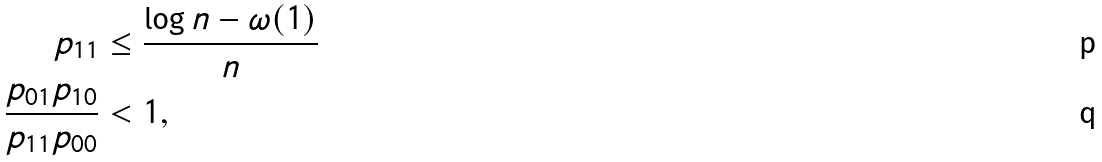<formula> <loc_0><loc_0><loc_500><loc_500>p _ { 1 1 } & \leq \frac { \log n - \omega ( 1 ) } { n } \\ \frac { p _ { 0 1 } p _ { 1 0 } } { p _ { 1 1 } p _ { 0 0 } } & < 1 ,</formula> 